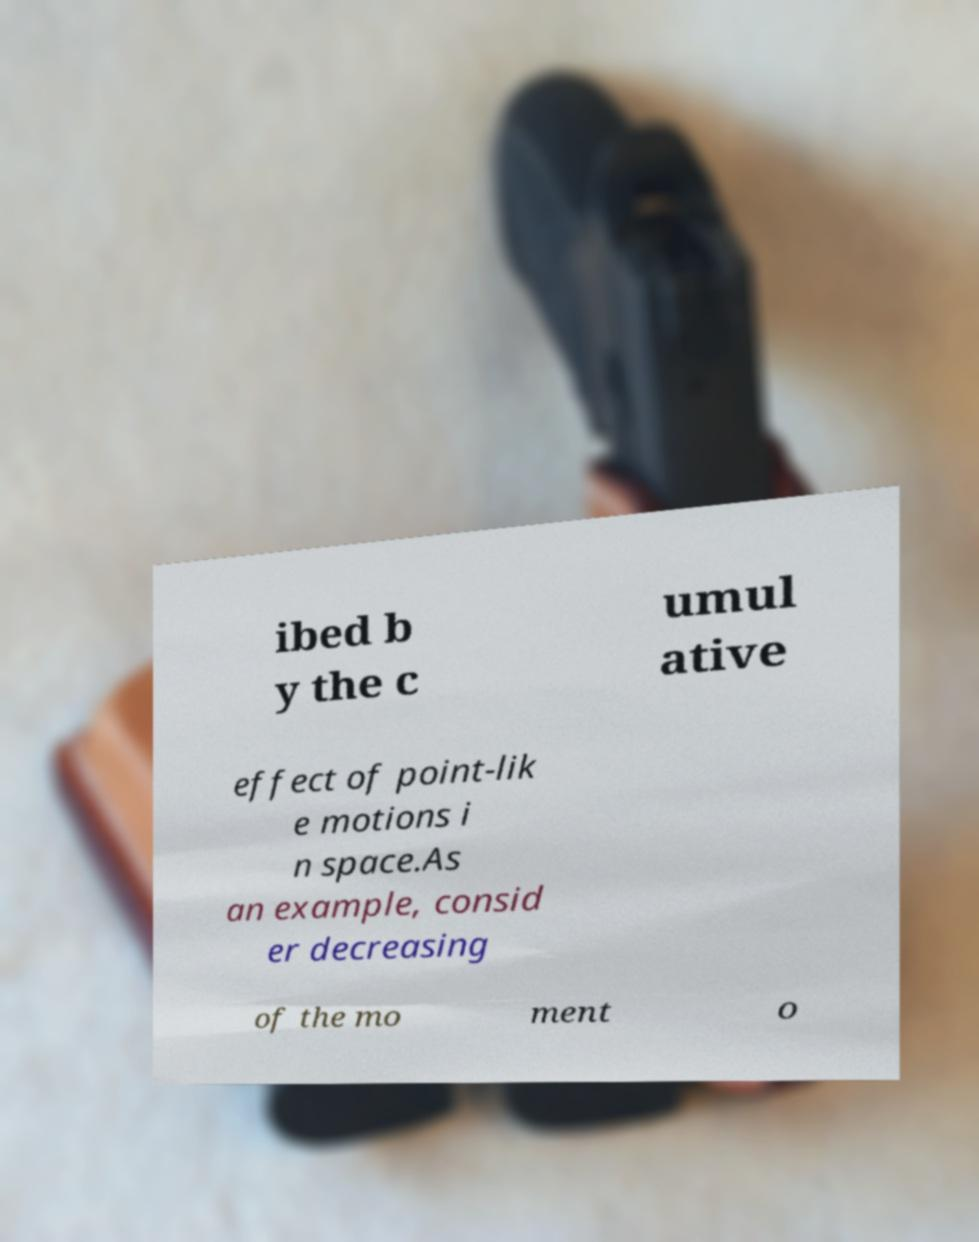What messages or text are displayed in this image? I need them in a readable, typed format. ibed b y the c umul ative effect of point-lik e motions i n space.As an example, consid er decreasing of the mo ment o 